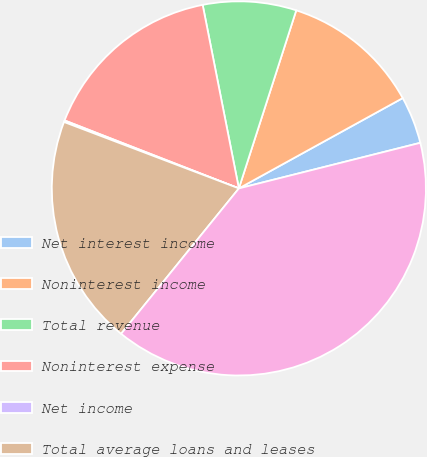Convert chart. <chart><loc_0><loc_0><loc_500><loc_500><pie_chart><fcel>Net interest income<fcel>Noninterest income<fcel>Total revenue<fcel>Noninterest expense<fcel>Net income<fcel>Total average loans and leases<fcel>Total average deposits<nl><fcel>4.1%<fcel>12.02%<fcel>8.06%<fcel>15.98%<fcel>0.14%<fcel>19.94%<fcel>39.75%<nl></chart> 